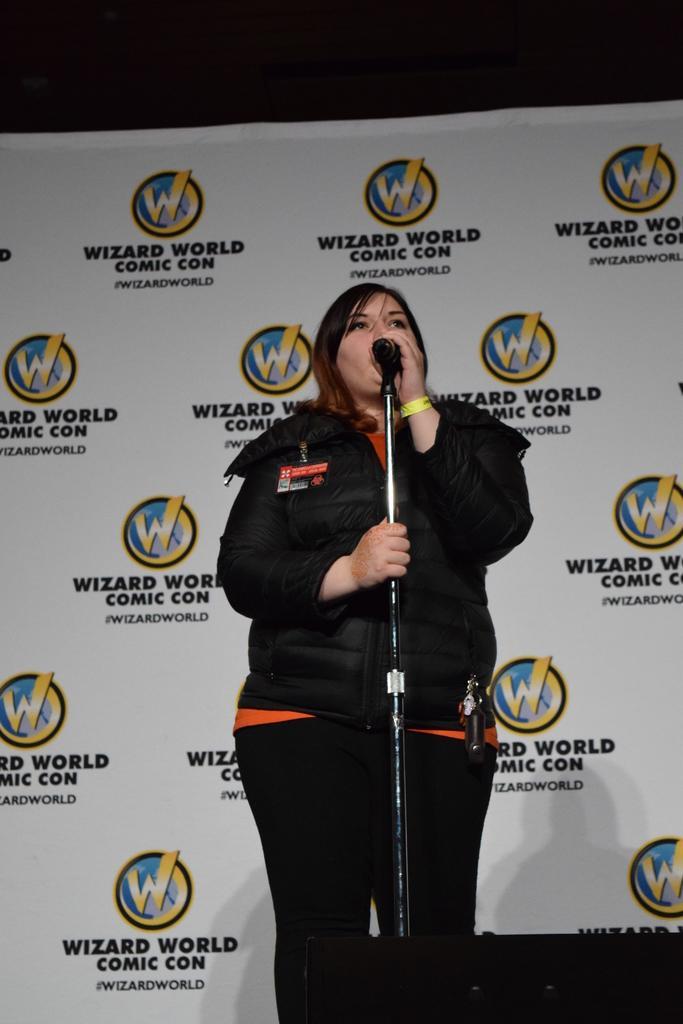Please provide a concise description of this image. In this picture we can see a woman, microphone and a banner in the background. 